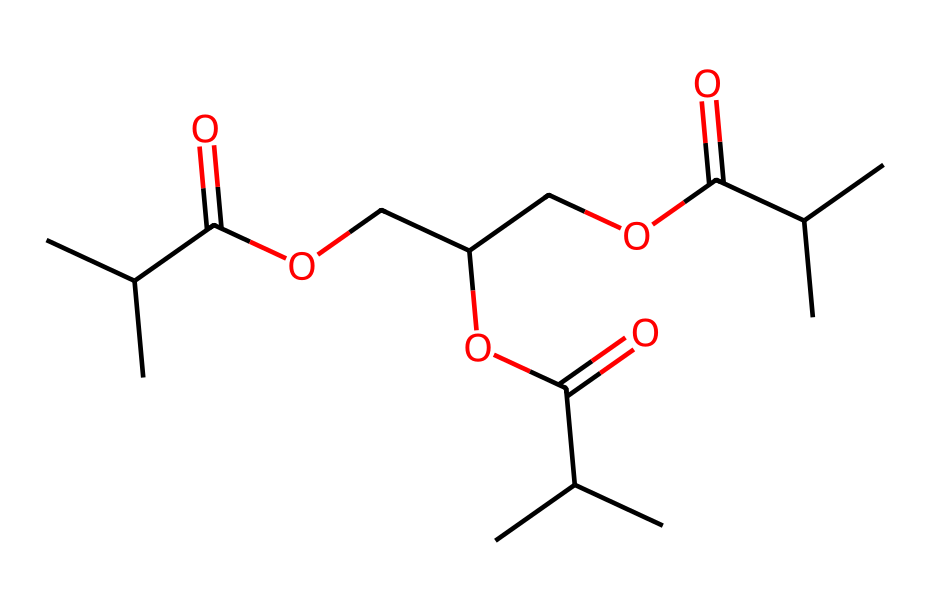What is the total number of carbon atoms in this polymer? By analyzing the SMILES string, we can count the carbon (C) atoms. The given structure has 14 carbon atoms in total.
Answer: 14 How many ester functional groups are present in this molecule? In the SMILES representation, an ester group is indicated by the presence of a carbonyl (C=O) adjacent to an ether linkage (C-O-C). By examining the structure, we can find three ester groups.
Answer: 3 What type of polymerization is likely involved in the formation of this chemical? This structure indicates a condensation polymerization in which monomers react to form a polymer while eliminating small molecules like water. The presence of multiple ester linkages suggests this type of polymerization.
Answer: condensation Which specific property does the presence of multiple ester linkages contribute to this polymer? The presence of multiple ester linkages contributes to the biodegradability of the polymer. During degradation, these ester bonds can be broken down by hydrolysis, leading to the environmental breakdown of the material.
Answer: biodegradability Is this polymer likely to be soluble in organic solvents? Given that this polymer has a significant number of alkyl chains and ester groups, it is likely to be somewhat soluble in organic solvents, which tend to solubilize similar hydrophobic compounds.
Answer: yes How does the branched structure impact the drug delivery performance of this polymer? The branched structure increases the surface area and can enhance the interaction with drug molecules, while also providing more sites for functionalization and controlling the release rate of drugs.
Answer: improves interaction 